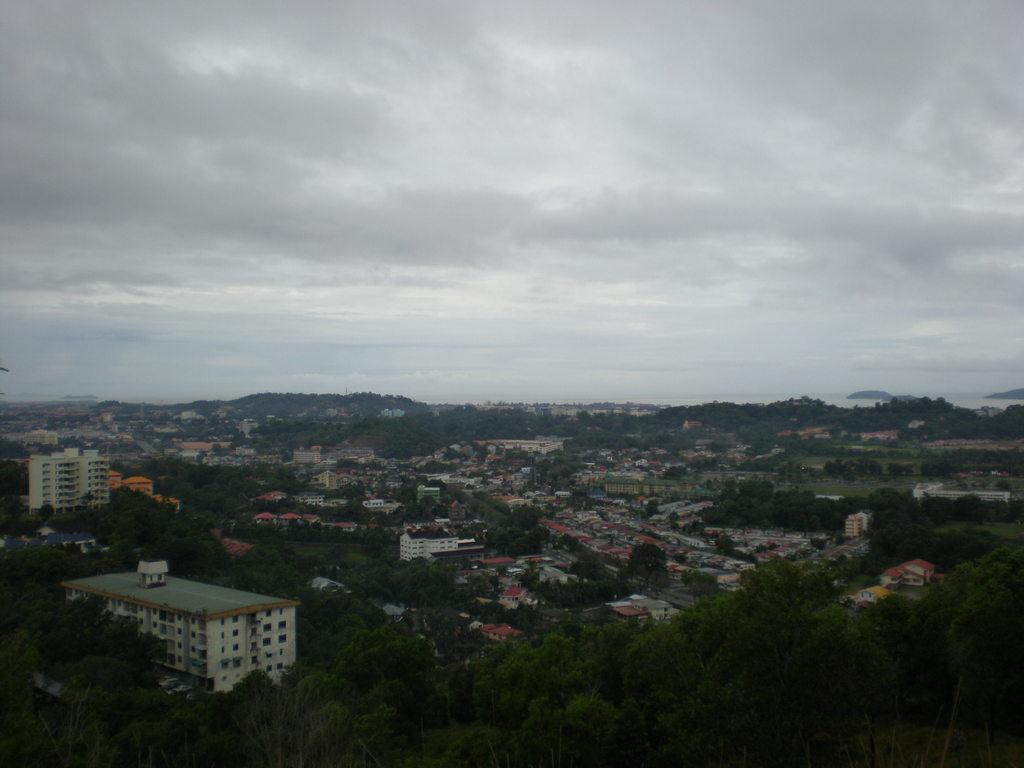What type of vegetation is at the bottom of the image? There are trees at the bottom of the image. What type of structures are in the middle of the image? There are buildings and houses in the middle of the image. What can be seen in the background of the image? There are clouds visible in the background of the image. What type of brass instrument is being played in the image? There is no brass instrument or any musical instrument present in the image. What type of rhythm can be heard in the image? There is no sound or rhythm present in the image, as it is a still image. 